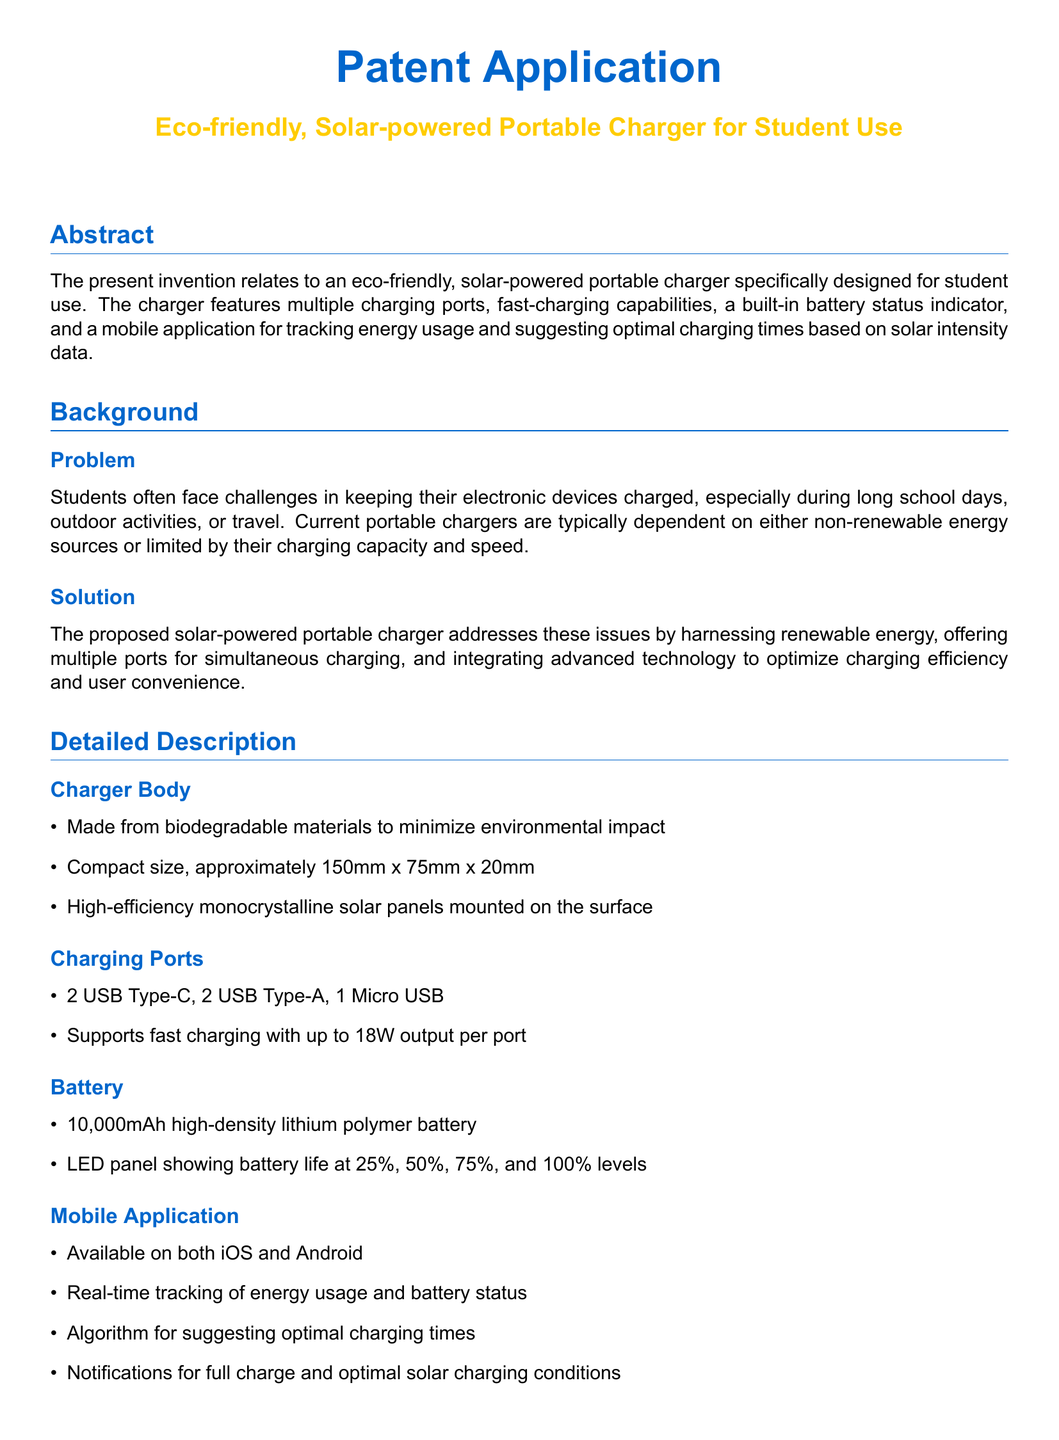What is the main purpose of the invention? The invention aims to provide an eco-friendly, solar-powered portable charger specifically designed for student use.
Answer: eco-friendly, solar-powered portable charger How many USB Type-C ports does the charger have? The document specifies that the charger includes 2 USB Type-C ports.
Answer: 2 What is the battery capacity of the charger? The charger features a 10,000mAh high-density lithium polymer battery.
Answer: 10,000mAh What materials are used to make the charger body? The charger body is made from biodegradable materials to minimize environmental impact.
Answer: biodegradable materials What does the mobile application track? The mobile application tracks energy usage and battery status in real time.
Answer: energy usage and battery status What is the output per port for fast charging? The charger supports fast charging with up to 18W output per port.
Answer: 18W How thick is the charger? The charger has a thickness of approximately 20mm.
Answer: 20mm What type of notifications does the mobile application provide? The application provides notifications for full charge and optimal solar charging conditions.
Answer: full charge and optimal solar charging conditions 